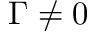<formula> <loc_0><loc_0><loc_500><loc_500>\Gamma \neq 0</formula> 